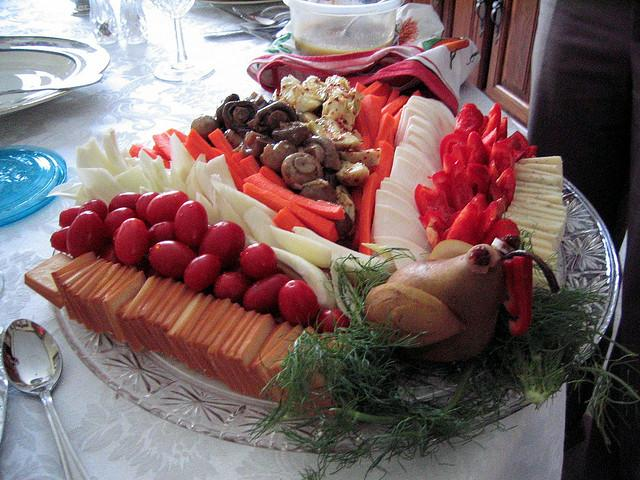What kind of food is between the mushrooms and carrots? artichoke hearts 